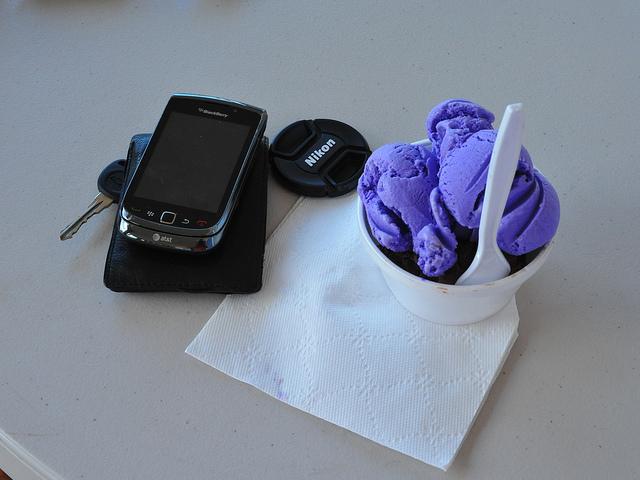What color is the lollipop?
Keep it brief. Purple. What color is the table?
Concise answer only. White. What color is the cup?
Keep it brief. White. Why are all of these small portions laid out?
Concise answer only. Unsure. What brand is the camera?
Write a very short answer. Nikon. What color is the ice cream?
Short answer required. Purple. Is this an old phone?
Write a very short answer. Yes. Is the phone in the picture on?
Give a very brief answer. No. What are they sitting on?
Be succinct. Table. What is the table made of?
Concise answer only. Wood. What is purple?
Concise answer only. Ice cream. Is this a new phone?
Quick response, please. No. Is there a car key visible?
Concise answer only. Yes. 